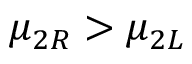Convert formula to latex. <formula><loc_0><loc_0><loc_500><loc_500>\mu _ { 2 R } > \mu _ { 2 L }</formula> 